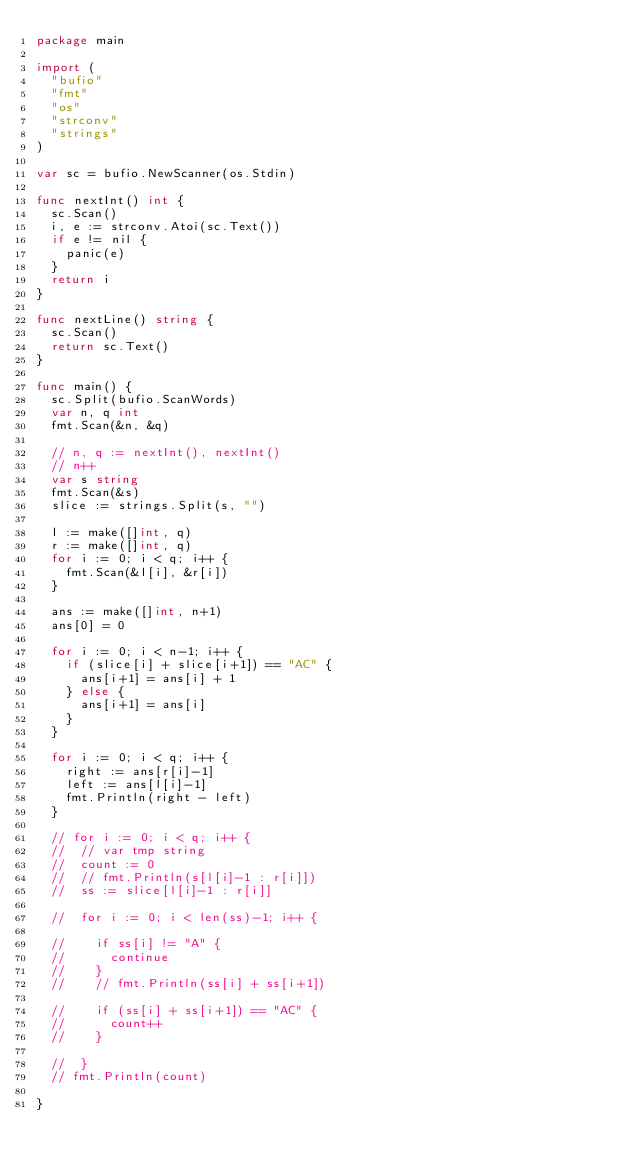<code> <loc_0><loc_0><loc_500><loc_500><_Go_>package main

import (
	"bufio"
	"fmt"
	"os"
	"strconv"
	"strings"
)

var sc = bufio.NewScanner(os.Stdin)

func nextInt() int {
	sc.Scan()
	i, e := strconv.Atoi(sc.Text())
	if e != nil {
		panic(e)
	}
	return i
}

func nextLine() string {
	sc.Scan()
	return sc.Text()
}

func main() {
	sc.Split(bufio.ScanWords)
	var n, q int
	fmt.Scan(&n, &q)

	// n, q := nextInt(), nextInt()
	// n++
	var s string
	fmt.Scan(&s)
	slice := strings.Split(s, "")

	l := make([]int, q)
	r := make([]int, q)
	for i := 0; i < q; i++ {
		fmt.Scan(&l[i], &r[i])
	}

	ans := make([]int, n+1)
	ans[0] = 0

	for i := 0; i < n-1; i++ {
		if (slice[i] + slice[i+1]) == "AC" {
			ans[i+1] = ans[i] + 1
		} else {
			ans[i+1] = ans[i]
		}
	}

	for i := 0; i < q; i++ {
		right := ans[r[i]-1]
		left := ans[l[i]-1]
		fmt.Println(right - left)
	}

	// for i := 0; i < q; i++ {
	// 	// var tmp string
	// 	count := 0
	// 	// fmt.Println(s[l[i]-1 : r[i]])
	// 	ss := slice[l[i]-1 : r[i]]

	// 	for i := 0; i < len(ss)-1; i++ {

	// 		if ss[i] != "A" {
	// 			continue
	// 		}
	// 		// fmt.Println(ss[i] + ss[i+1])

	// 		if (ss[i] + ss[i+1]) == "AC" {
	// 			count++
	// 		}

	// 	}
	// fmt.Println(count)

}
</code> 